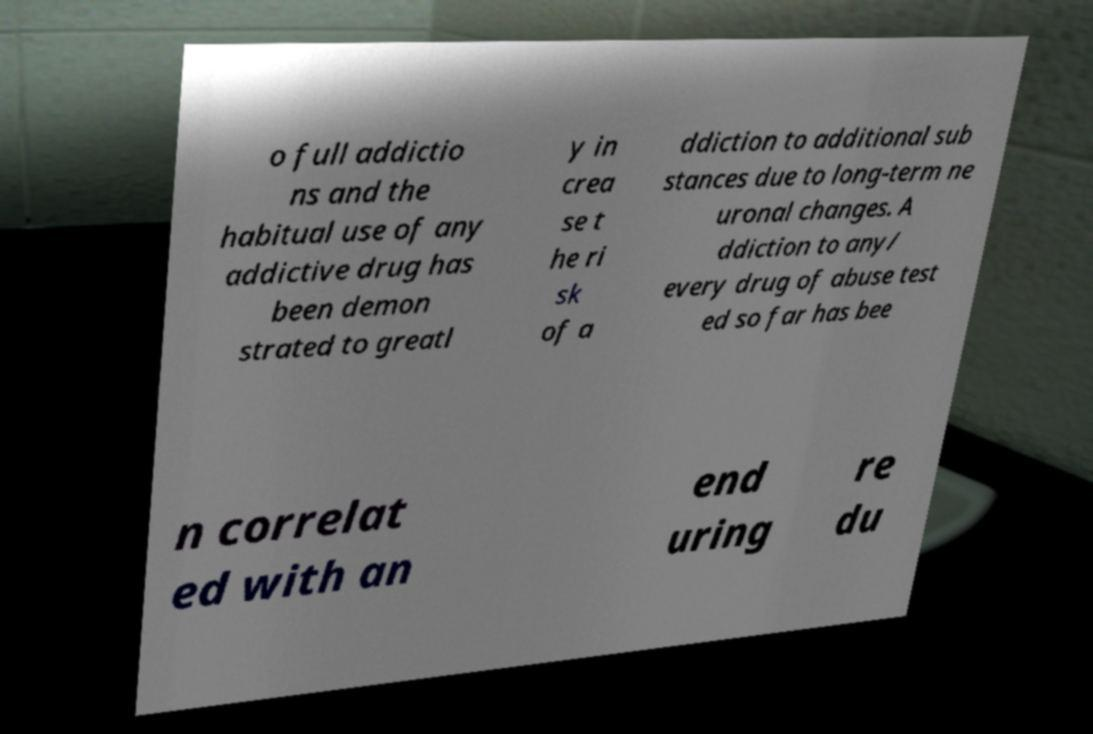I need the written content from this picture converted into text. Can you do that? o full addictio ns and the habitual use of any addictive drug has been demon strated to greatl y in crea se t he ri sk of a ddiction to additional sub stances due to long-term ne uronal changes. A ddiction to any/ every drug of abuse test ed so far has bee n correlat ed with an end uring re du 